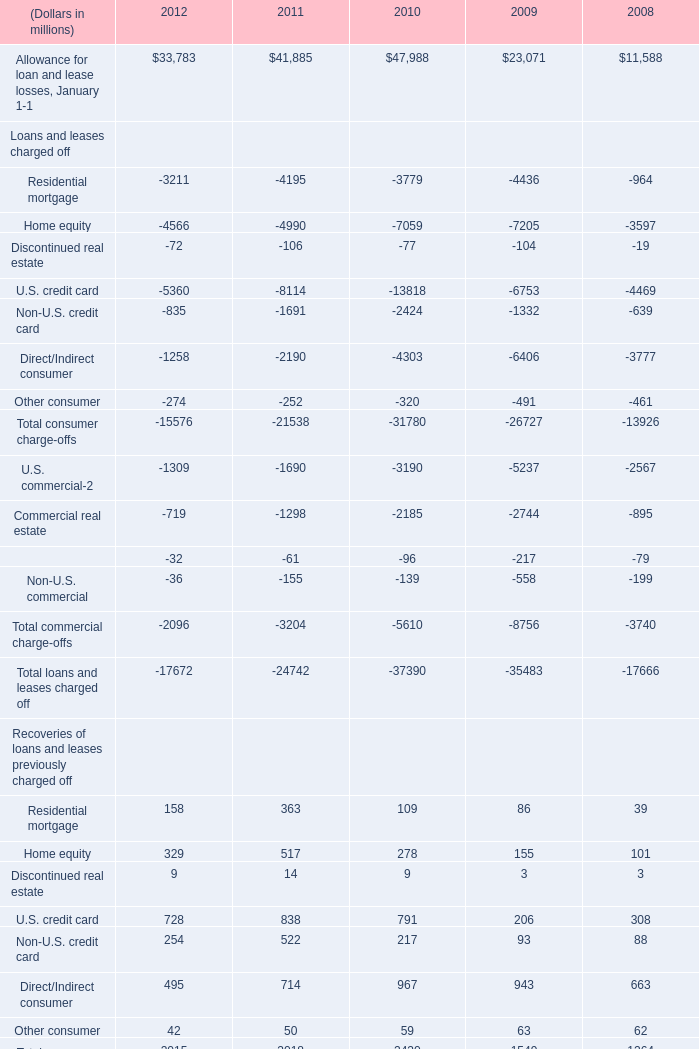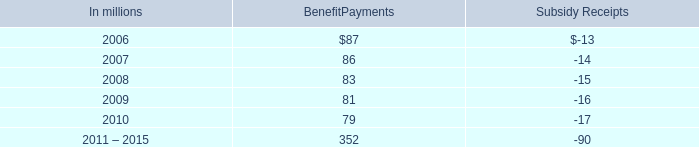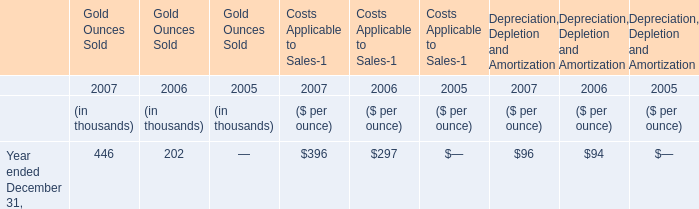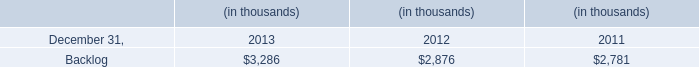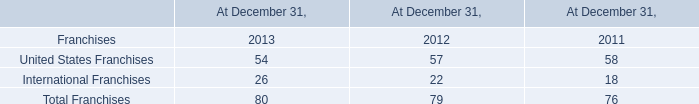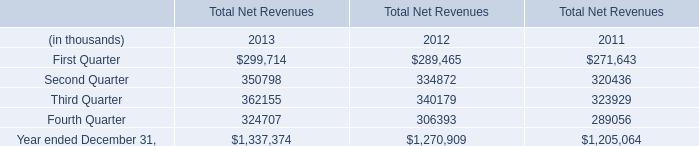In terms of recoveries of loans and leases previously charged off,what's the average of residential mortgage and home equity and discontinued real estate in 2012?" (in million) 
Computations: (((158 + 329) + 9) / 3)
Answer: 165.33333. 